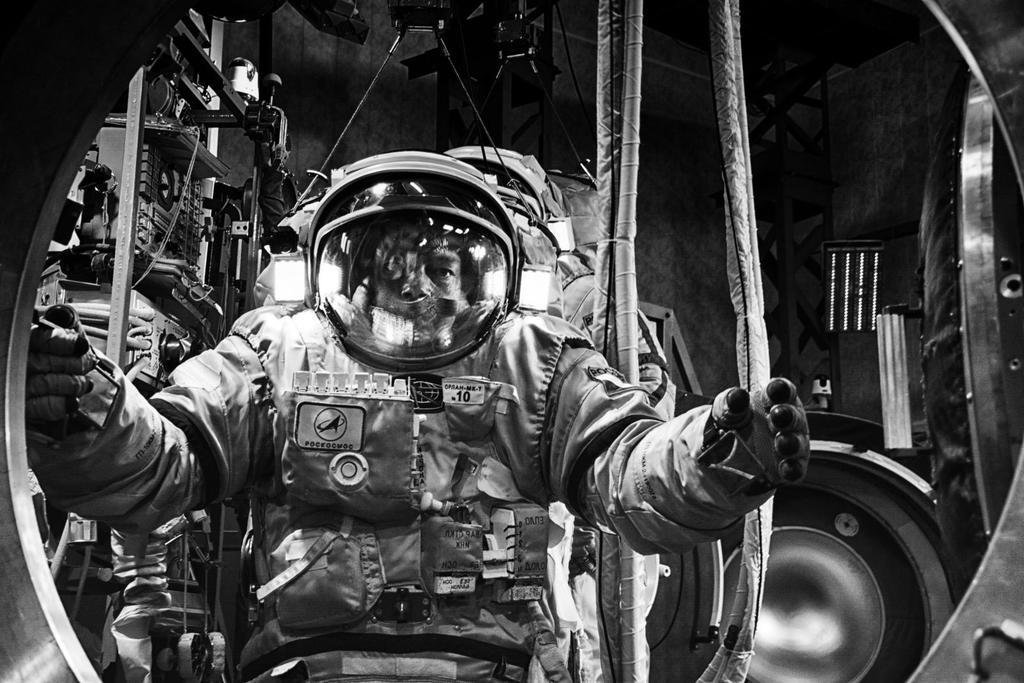What is the color scheme of the image? The image is black and white. What is the main subject of the image? There is an astronaut in the image. What can be seen in the background of the image? There are objects placed on shelves and a wall visible in the background of the image. What type of yam is being held by the astronaut in the image? There is no yam present in the image; the astronaut is not holding any object. How does the fire affect the astronaut in the image? There is no fire present in the image, so it does not affect the astronaut. 